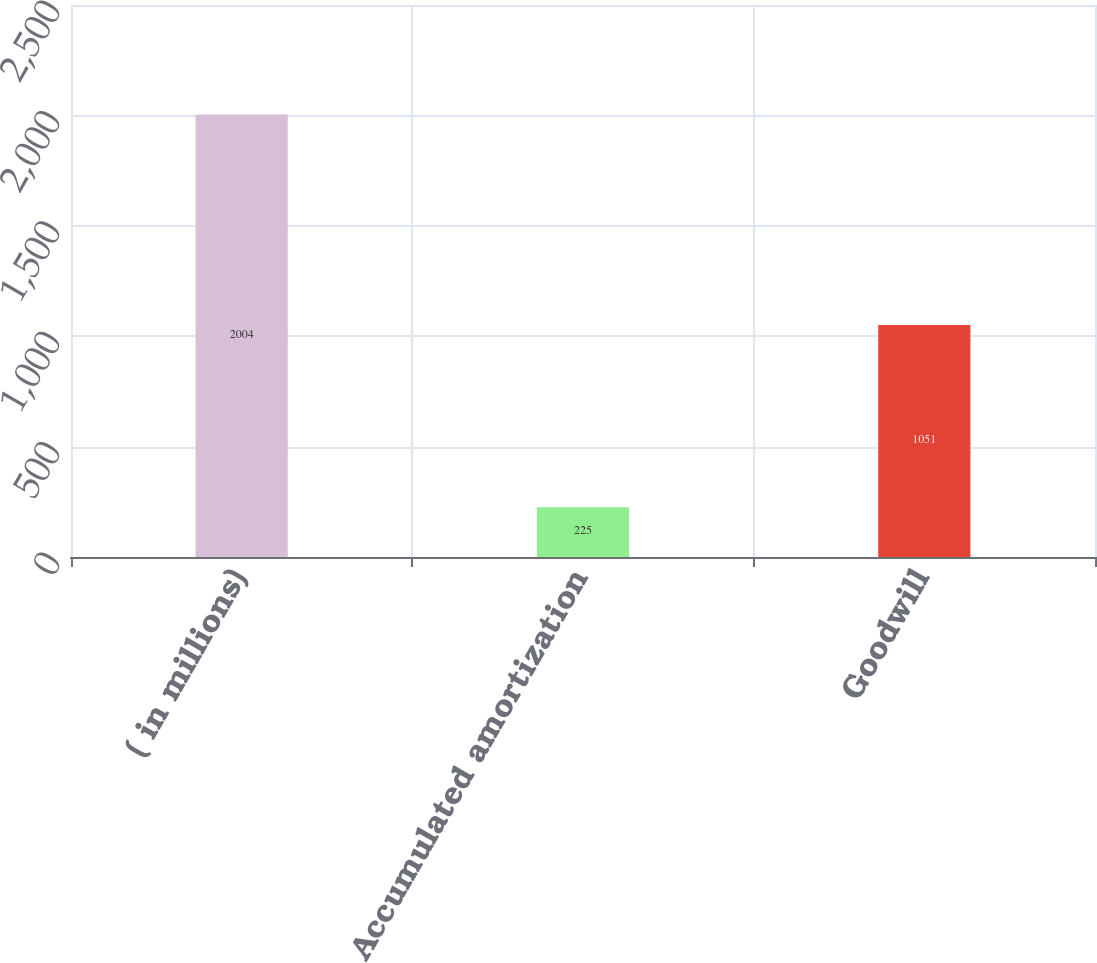<chart> <loc_0><loc_0><loc_500><loc_500><bar_chart><fcel>( in millions)<fcel>Accumulated amortization<fcel>Goodwill<nl><fcel>2004<fcel>225<fcel>1051<nl></chart> 